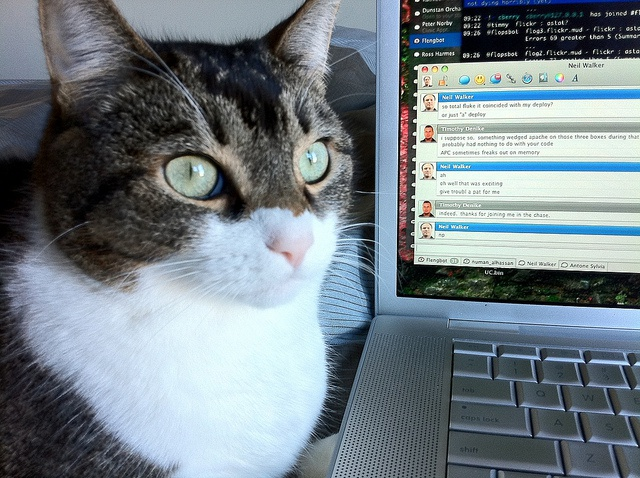Describe the objects in this image and their specific colors. I can see cat in darkgray, black, lightblue, and gray tones, laptop in darkgray, ivory, black, gray, and purple tones, people in darkgray, ivory, and tan tones, people in darkgray, salmon, white, and black tones, and people in darkgray, tan, and beige tones in this image. 